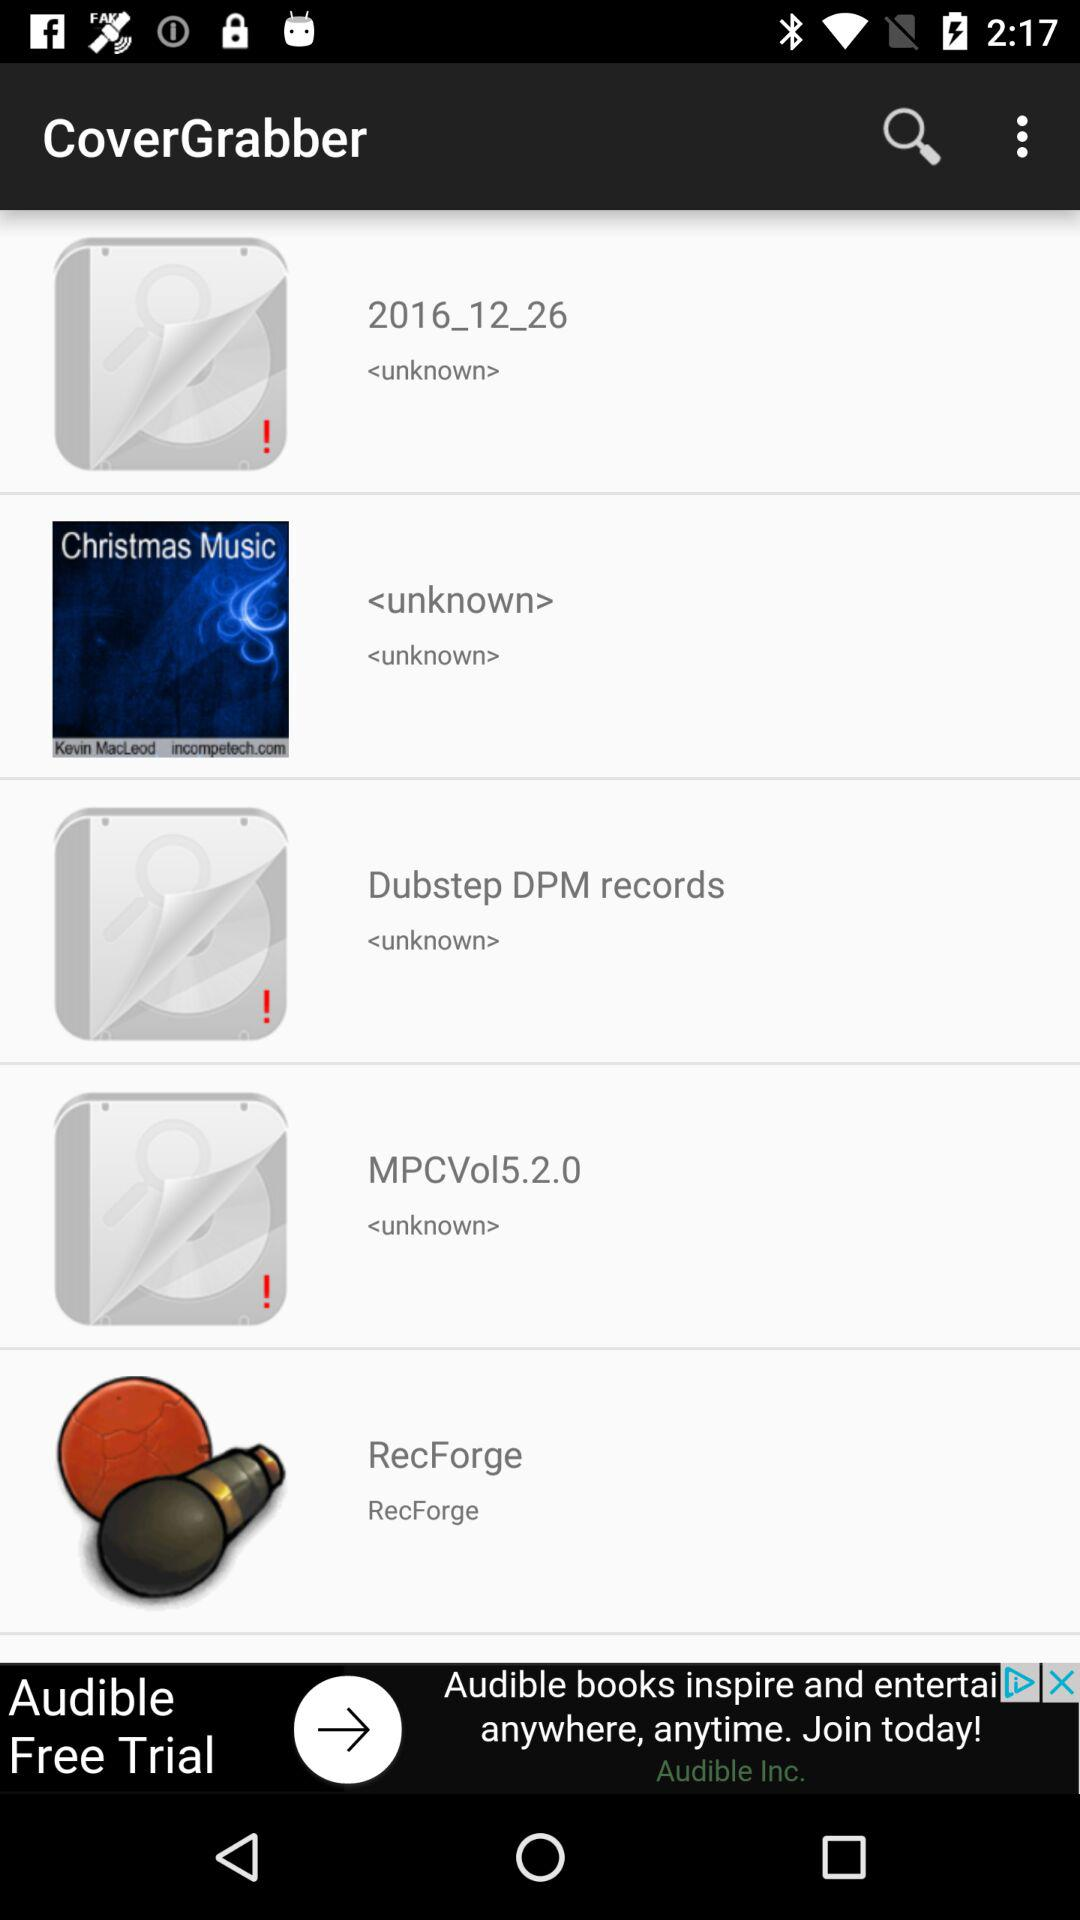What is the name of the application? The name of the application is "CoverGrabber". 